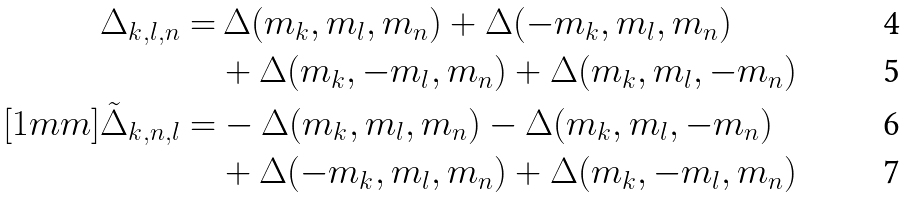Convert formula to latex. <formula><loc_0><loc_0><loc_500><loc_500>\Delta _ { k , l , n } = & \, \Delta ( m _ { k } , m _ { l } , m _ { n } ) + \Delta ( - m _ { k } , m _ { l } , m _ { n } ) \\ & + \Delta ( m _ { k } , - m _ { l } , m _ { n } ) + \Delta ( m _ { k } , m _ { l } , - m _ { n } ) \\ [ 1 m m ] \tilde { \Delta } _ { k , n , l } = & - \Delta ( m _ { k } , m _ { l } , m _ { n } ) - \Delta ( m _ { k } , m _ { l } , - m _ { n } ) \\ & + \Delta ( - m _ { k } , m _ { l } , m _ { n } ) + \Delta ( m _ { k } , - m _ { l } , m _ { n } )</formula> 